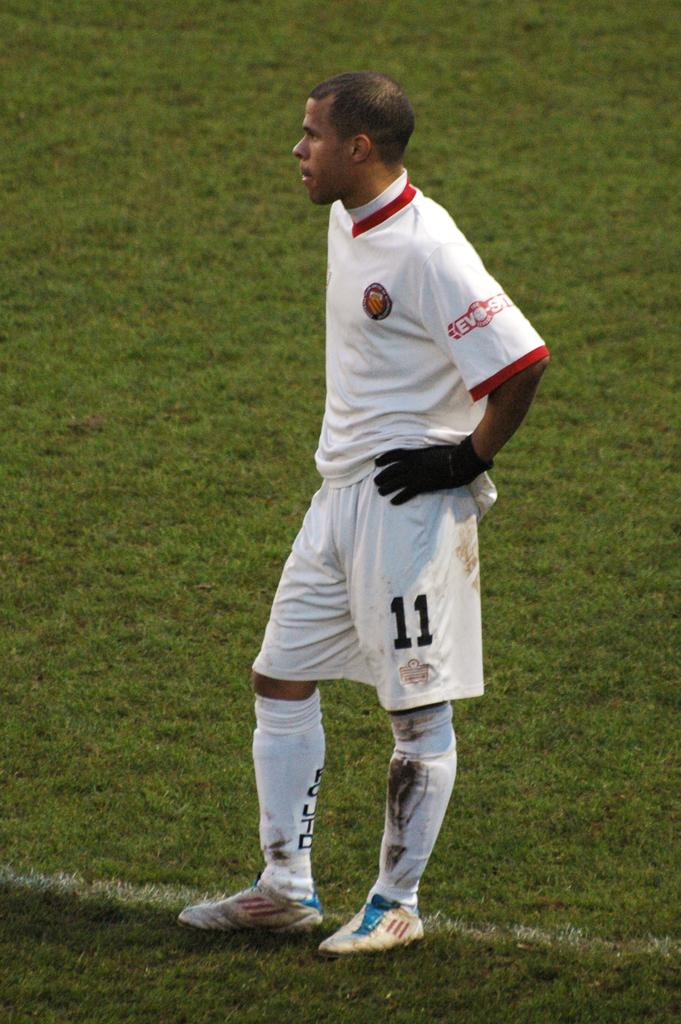Provide a one-sentence caption for the provided image. Soccer player wearing number 11 standing on the grass. 